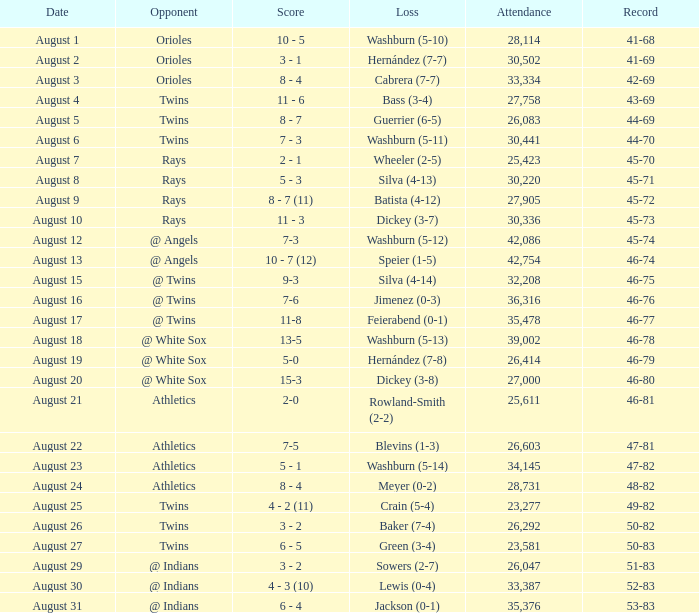What was the loss for August 19? Hernández (7-8). 